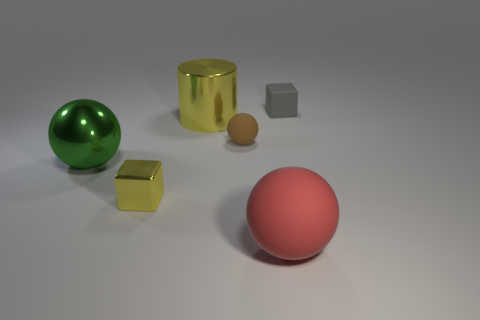Add 2 small gray rubber objects. How many objects exist? 8 Subtract all cylinders. How many objects are left? 5 Subtract 1 yellow cubes. How many objects are left? 5 Subtract all large gray matte balls. Subtract all big red balls. How many objects are left? 5 Add 2 green things. How many green things are left? 3 Add 2 large yellow things. How many large yellow things exist? 3 